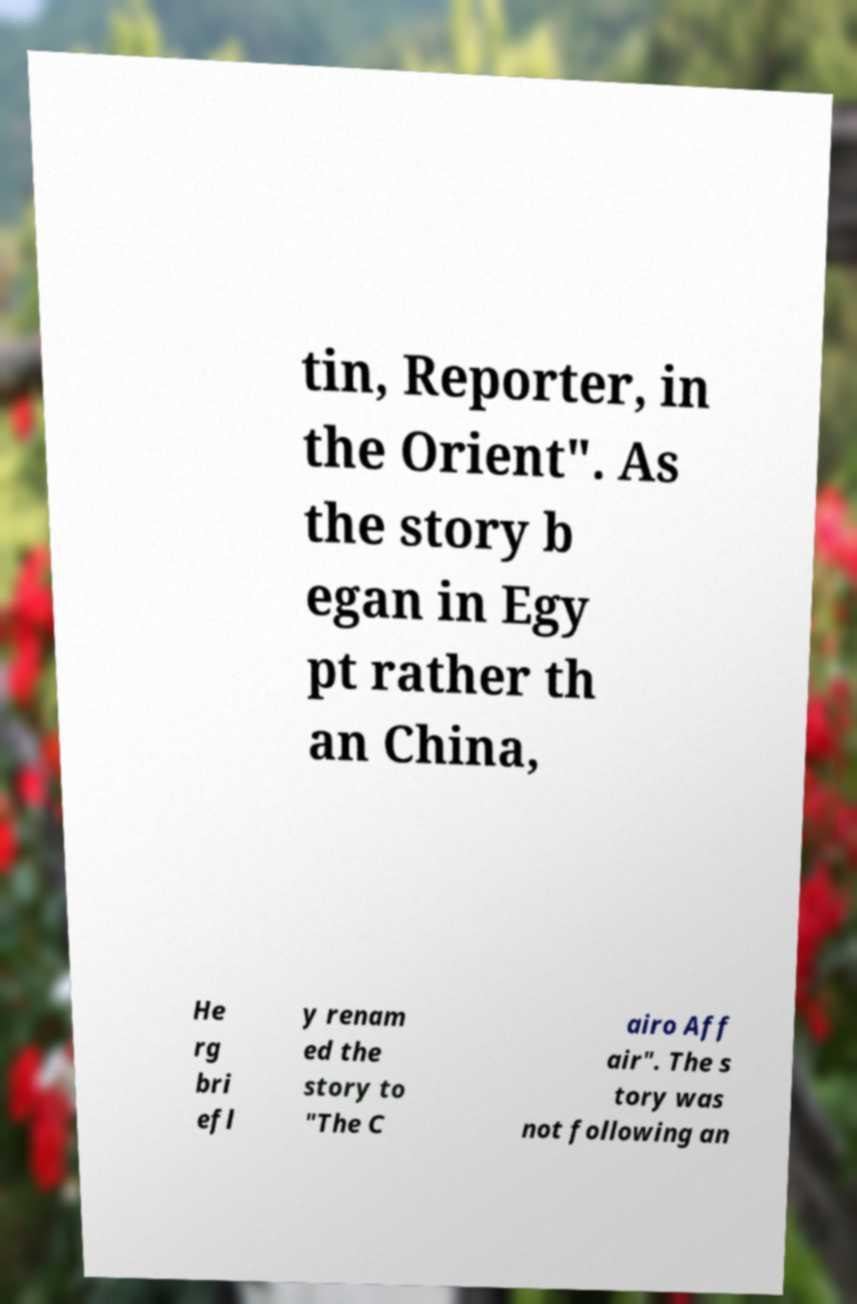Can you accurately transcribe the text from the provided image for me? tin, Reporter, in the Orient". As the story b egan in Egy pt rather th an China, He rg bri efl y renam ed the story to "The C airo Aff air". The s tory was not following an 